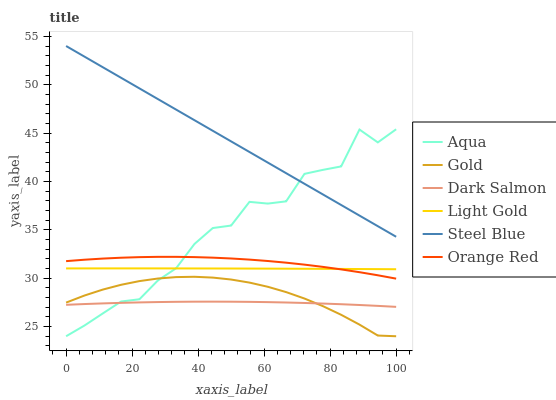Does Dark Salmon have the minimum area under the curve?
Answer yes or no. Yes. Does Steel Blue have the maximum area under the curve?
Answer yes or no. Yes. Does Aqua have the minimum area under the curve?
Answer yes or no. No. Does Aqua have the maximum area under the curve?
Answer yes or no. No. Is Steel Blue the smoothest?
Answer yes or no. Yes. Is Aqua the roughest?
Answer yes or no. Yes. Is Dark Salmon the smoothest?
Answer yes or no. No. Is Dark Salmon the roughest?
Answer yes or no. No. Does Gold have the lowest value?
Answer yes or no. Yes. Does Dark Salmon have the lowest value?
Answer yes or no. No. Does Steel Blue have the highest value?
Answer yes or no. Yes. Does Aqua have the highest value?
Answer yes or no. No. Is Light Gold less than Steel Blue?
Answer yes or no. Yes. Is Steel Blue greater than Dark Salmon?
Answer yes or no. Yes. Does Aqua intersect Steel Blue?
Answer yes or no. Yes. Is Aqua less than Steel Blue?
Answer yes or no. No. Is Aqua greater than Steel Blue?
Answer yes or no. No. Does Light Gold intersect Steel Blue?
Answer yes or no. No. 